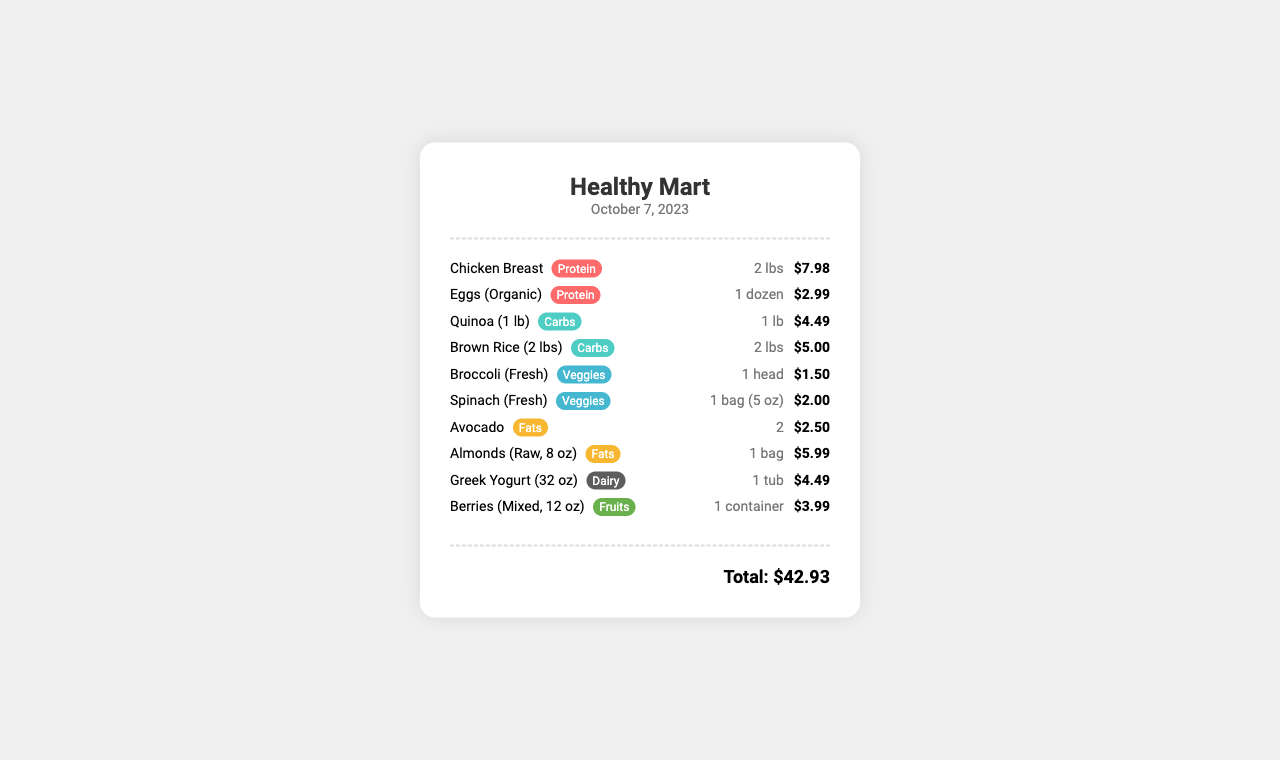What is the store name? The store name is prominently displayed at the top of the receipt.
Answer: Healthy Mart How many pounds of chicken breast were purchased? The quantity of chicken breast is listed next to the item name.
Answer: 2 lbs What is the price of organic eggs? The price for organic eggs can be found next to the item on the receipt.
Answer: $2.99 What type of meal prep item is the spinach classified as? The classification of spinach can be found marked next to its name in the item list.
Answer: Vegetables What is the total amount spent? The total amount is calculated and shown at the bottom of the receipt.
Answer: $42.93 How many avocados are listed? The quantity of avocados is specified directly in the receipt under the item name.
Answer: 2 What is the weight of the quinoa purchased? The weight of quinoa is mentioned in the item description on the receipt.
Answer: 1 lb What category does Greek yogurt fall under? The category is provided next to the Greek yogurt in the items list.
Answer: Dairy Which protein source item has the highest price? The prices of protein sources are compared to identify the highest one listed.
Answer: Chicken Breast 